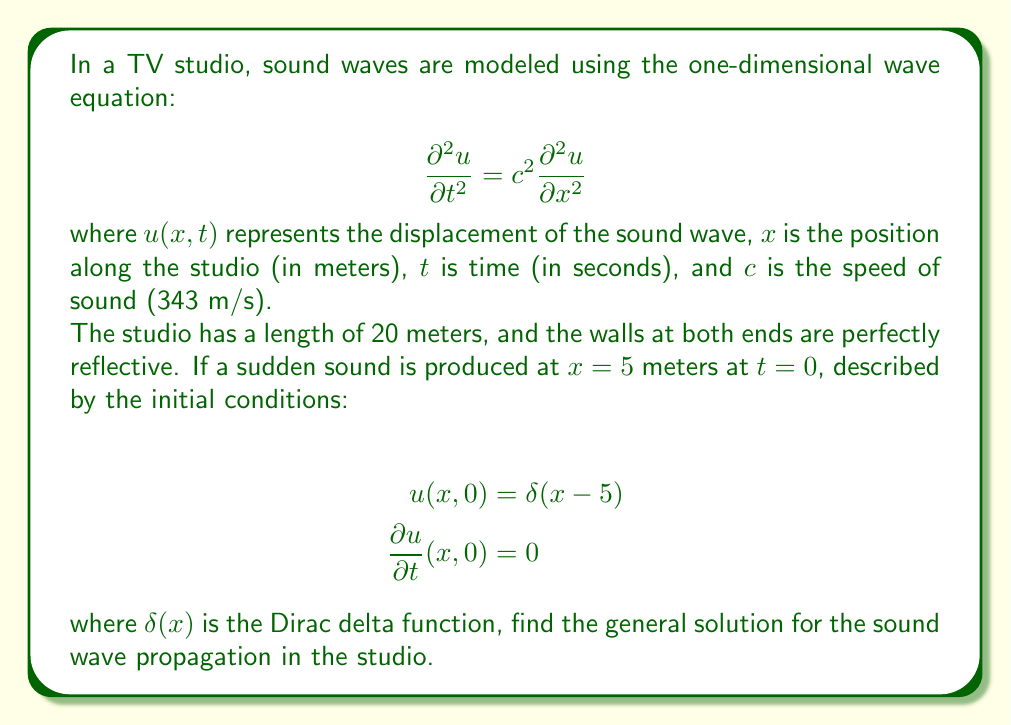Give your solution to this math problem. To solve this wave equation with the given boundary and initial conditions, we'll follow these steps:

1) The general solution for the wave equation with fixed ends (perfectly reflective walls) is given by:

   $$u(x,t) = \sum_{n=1}^{\infty} \left(A_n \cos(\omega_n t) + B_n \sin(\omega_n t)\right) \sin(\frac{n\pi x}{L})$$

   where $L$ is the length of the studio (20 meters), and $\omega_n = \frac{n\pi c}{L}$.

2) We need to find the coefficients $A_n$ and $B_n$ using the initial conditions.

3) For the first initial condition $u(x,0) = \delta(x-5)$:

   $$\delta(x-5) = \sum_{n=1}^{\infty} A_n \sin(\frac{n\pi x}{L})$$

   Multiplying both sides by $\sin(\frac{m\pi x}{L})$ and integrating from 0 to L:

   $$\int_0^L \delta(x-5) \sin(\frac{m\pi x}{L}) dx = \sum_{n=1}^{\infty} A_n \int_0^L \sin(\frac{n\pi x}{L}) \sin(\frac{m\pi x}{L}) dx$$

   The left side simplifies to $\sin(\frac{m\pi 5}{L})$, and the right side simplifies to $\frac{L}{2} A_m$. Thus:

   $$A_n = \frac{2}{L} \sin(\frac{n\pi 5}{L}) = \frac{1}{10} \sin(\frac{n\pi}{4})$$

4) For the second initial condition $\frac{\partial u}{\partial t}(x,0) = 0$:

   $$0 = \sum_{n=1}^{\infty} B_n \omega_n \sin(\frac{n\pi x}{L})$$

   This implies that all $B_n = 0$.

5) Therefore, the general solution is:

   $$u(x,t) = \frac{1}{10} \sum_{n=1}^{\infty} \sin(\frac{n\pi}{4}) \cos(\frac{n\pi c t}{L}) \sin(\frac{n\pi x}{L})$$

   Substituting the values of $c$ and $L$:

   $$u(x,t) = \frac{1}{10} \sum_{n=1}^{\infty} \sin(\frac{n\pi}{4}) \cos(17.15nt) \sin(\frac{n\pi x}{20})$$
Answer: The general solution for the sound wave propagation in the TV studio is:

$$u(x,t) = \frac{1}{10} \sum_{n=1}^{\infty} \sin(\frac{n\pi}{4}) \cos(17.15nt) \sin(\frac{n\pi x}{20})$$ 